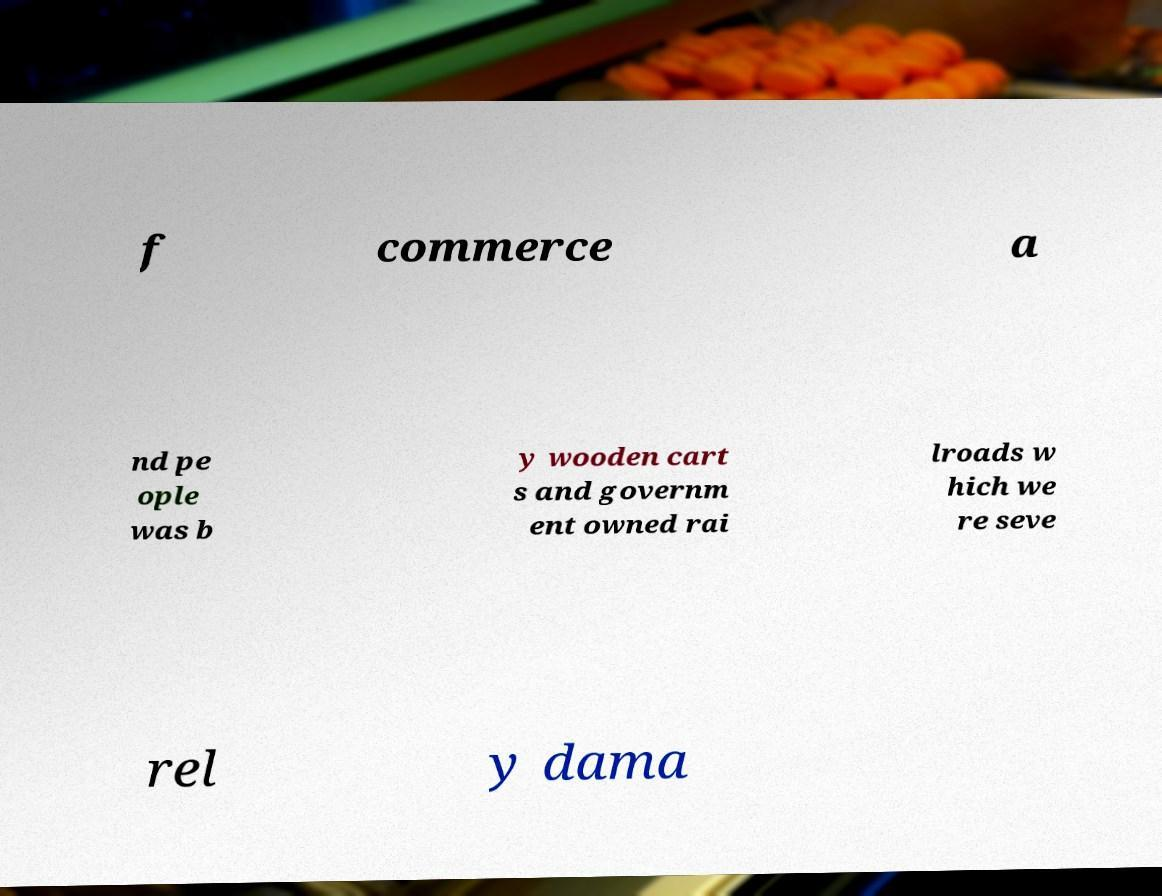Can you accurately transcribe the text from the provided image for me? f commerce a nd pe ople was b y wooden cart s and governm ent owned rai lroads w hich we re seve rel y dama 